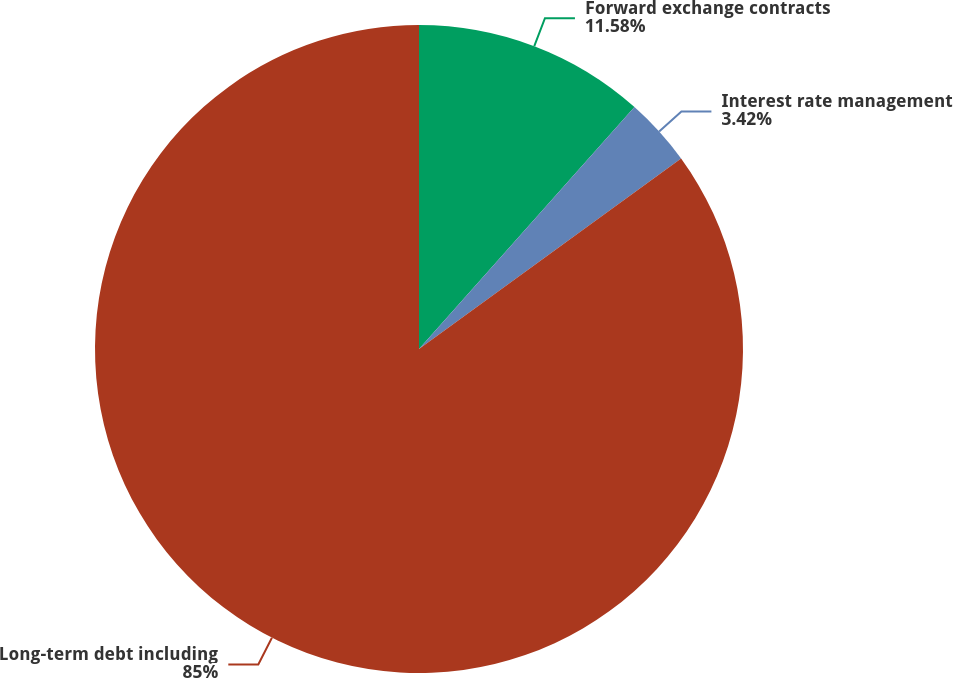Convert chart to OTSL. <chart><loc_0><loc_0><loc_500><loc_500><pie_chart><fcel>Forward exchange contracts<fcel>Interest rate management<fcel>Long-term debt including<nl><fcel>11.58%<fcel>3.42%<fcel>85.01%<nl></chart> 